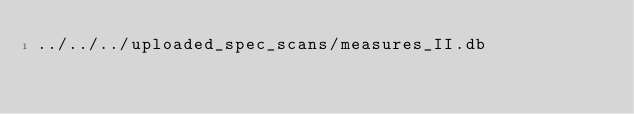<code> <loc_0><loc_0><loc_500><loc_500><_SML_>../../../uploaded_spec_scans/measures_II.db
</code> 